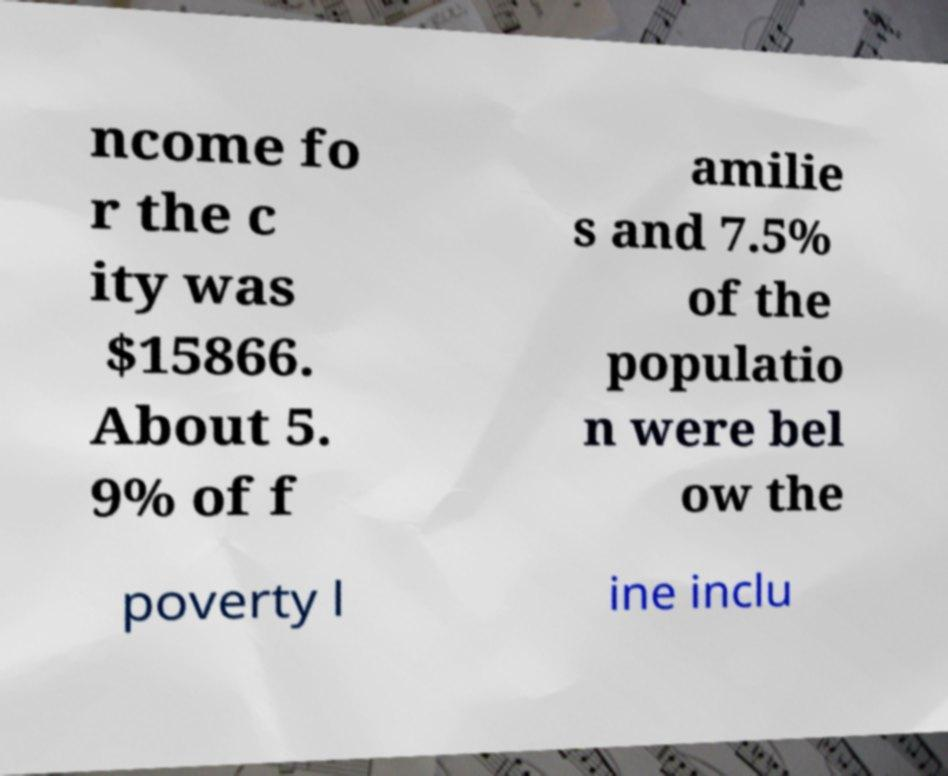Can you read and provide the text displayed in the image?This photo seems to have some interesting text. Can you extract and type it out for me? ncome fo r the c ity was $15866. About 5. 9% of f amilie s and 7.5% of the populatio n were bel ow the poverty l ine inclu 